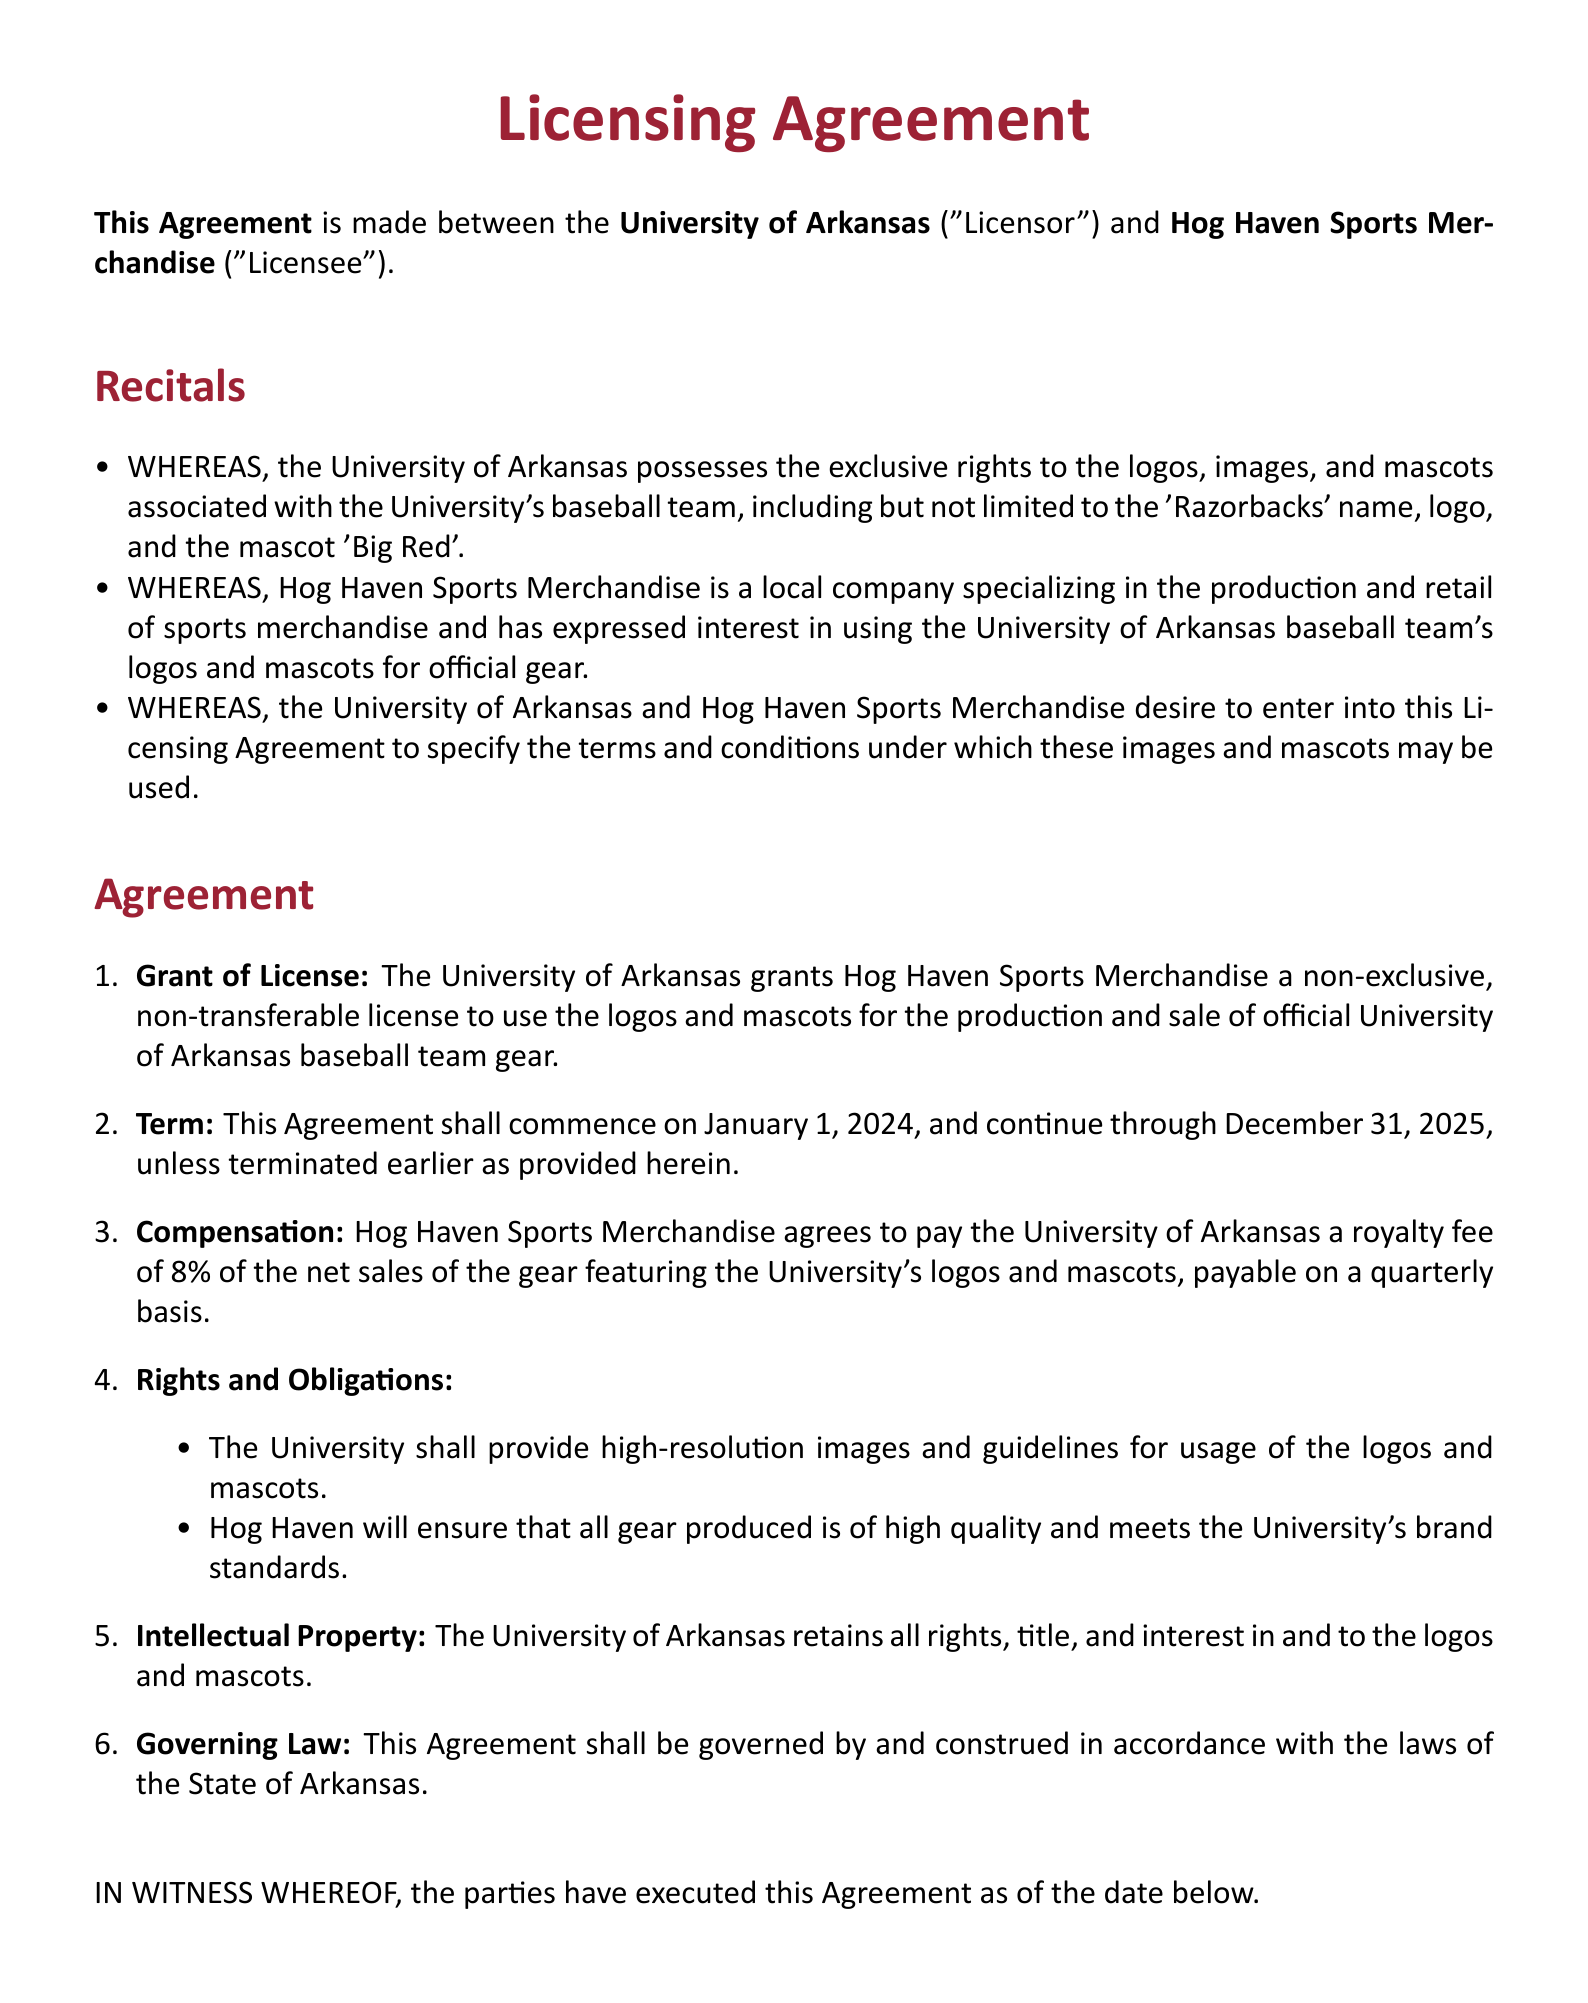What is the name of the local sports merchandise company? The document states the name of the company as "Hog Haven Sports Merchandise."
Answer: Hog Haven Sports Merchandise What percentage royalty fee will Hog Haven pay? The document specifies that the royalty fee is 8% of the net sales.
Answer: 8% When does the agreement commence? The agreement states it will commence on January 1, 2024.
Answer: January 1, 2024 What is the duration of the agreement? The document mentions that the agreement will continue through December 31, 2025.
Answer: December 31, 2025 Who is the Athletic Director of the University of Arkansas? The document identifies the Athletic Director as "John Smith."
Answer: John Smith What type of license is granted to Hog Haven? It is specified as a "non-exclusive, non-transferable license."
Answer: non-exclusive, non-transferable license What quality standard must the merchandise meet? The document states that the gear must meet the University's brand standards.
Answer: University's brand standards What will the state law govern the agreement? The governing law for the agreement is stated as the law of the State of Arkansas.
Answer: State of Arkansas What is the mascot associated with the University of Arkansas baseball team? The document mentions the mascot being referred to as "Big Red."
Answer: Big Red 